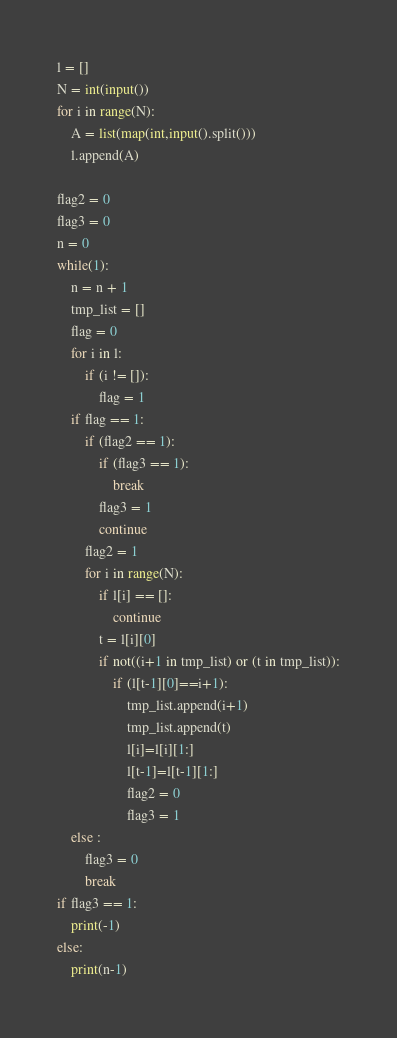<code> <loc_0><loc_0><loc_500><loc_500><_Python_>l = []
N = int(input())
for i in range(N):
    A = list(map(int,input().split()))
    l.append(A)

flag2 = 0
flag3 = 0
n = 0
while(1):
    n = n + 1
    tmp_list = []
    flag = 0
    for i in l:
        if (i != []):
            flag = 1
    if flag == 1:
        if (flag2 == 1):
            if (flag3 == 1):
                break
            flag3 = 1
            continue
        flag2 = 1
        for i in range(N):
            if l[i] == []:
                continue
            t = l[i][0]
            if not((i+1 in tmp_list) or (t in tmp_list)):
                if (l[t-1][0]==i+1):
                    tmp_list.append(i+1)
                    tmp_list.append(t)
                    l[i]=l[i][1:]
                    l[t-1]=l[t-1][1:]
                    flag2 = 0
                    flag3 = 1
    else :
        flag3 = 0
        break
if flag3 == 1:
    print(-1)
else:
    print(n-1)</code> 